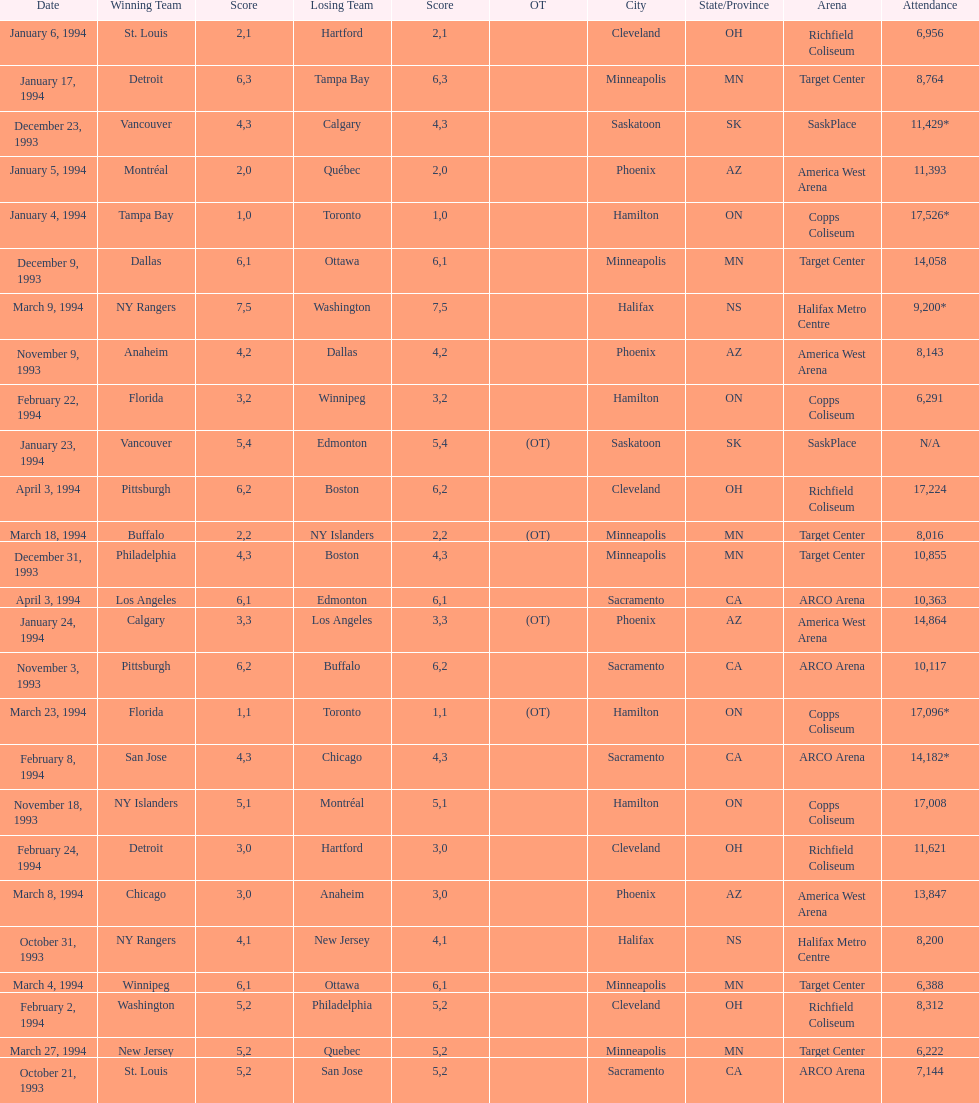How many events occurred in minneapolis, mn? 6. 